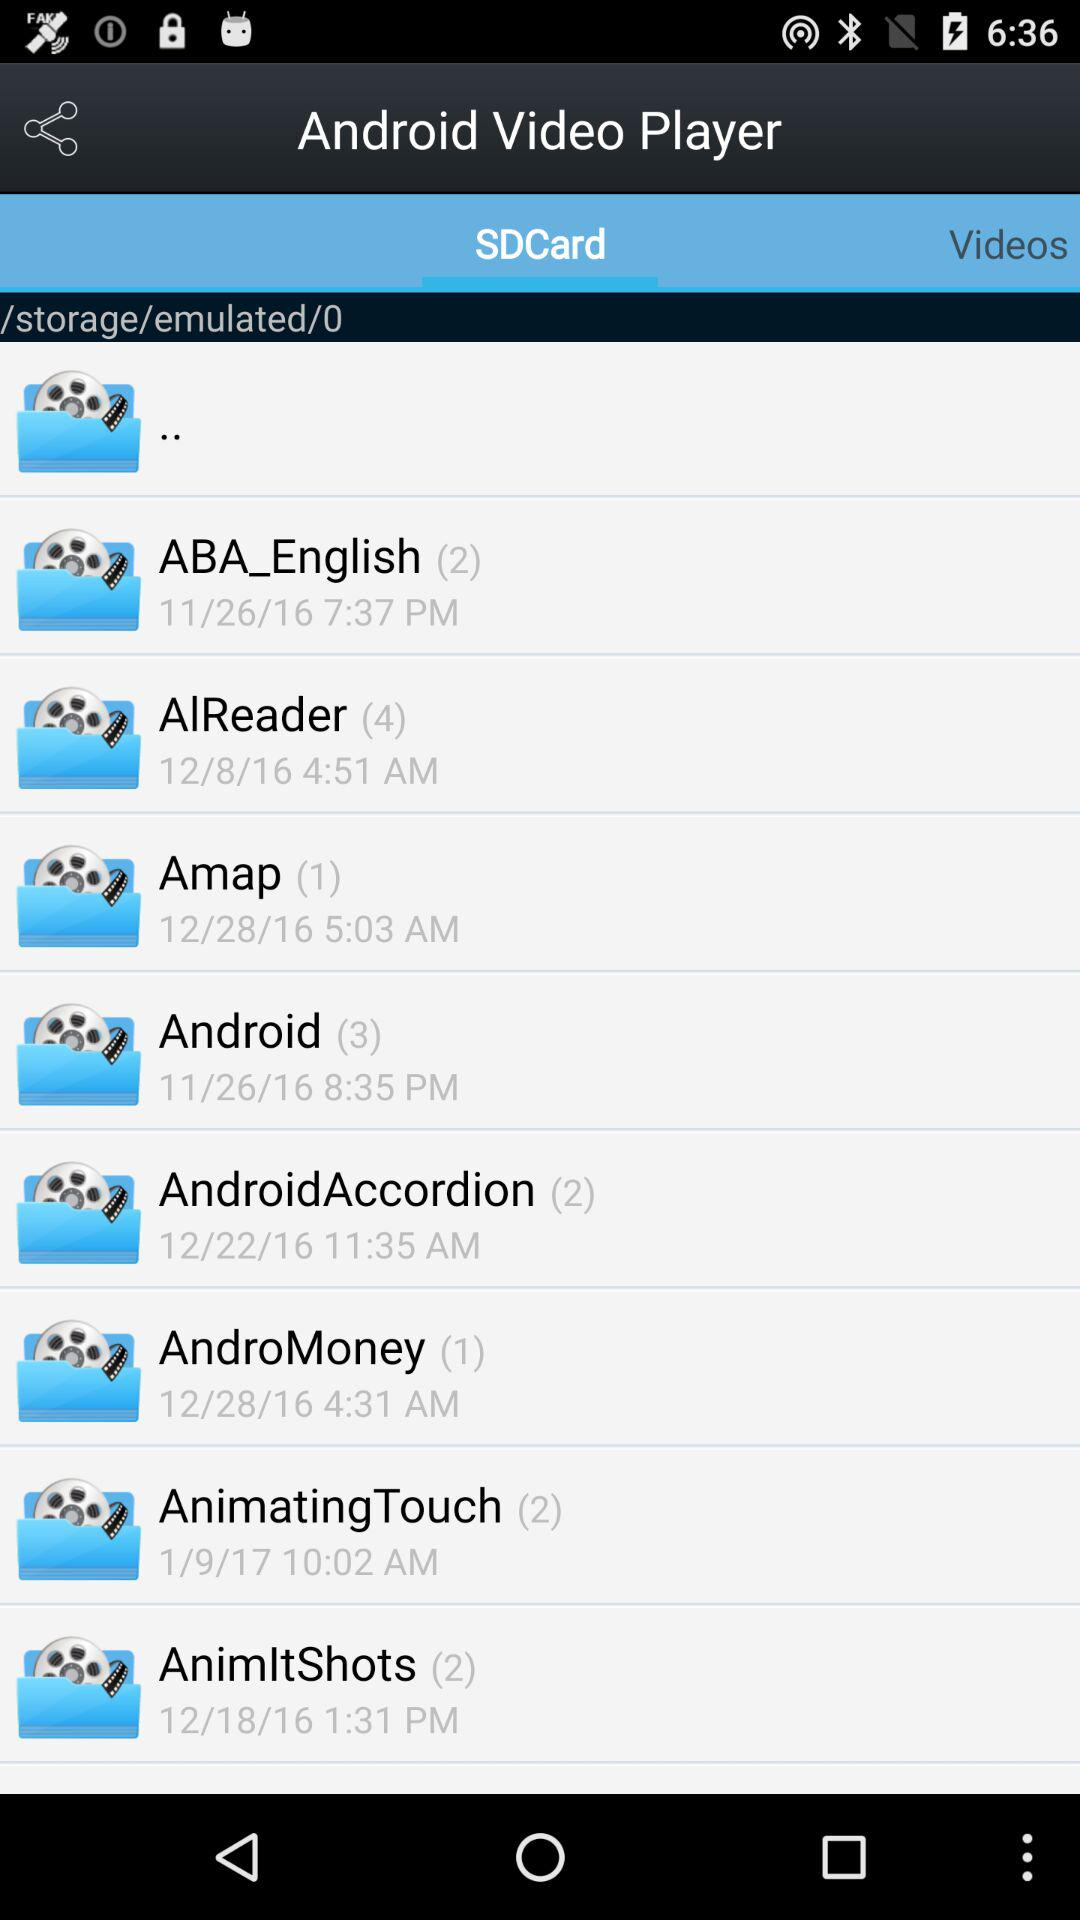What is the application name? The application name is "Android Video Player". 